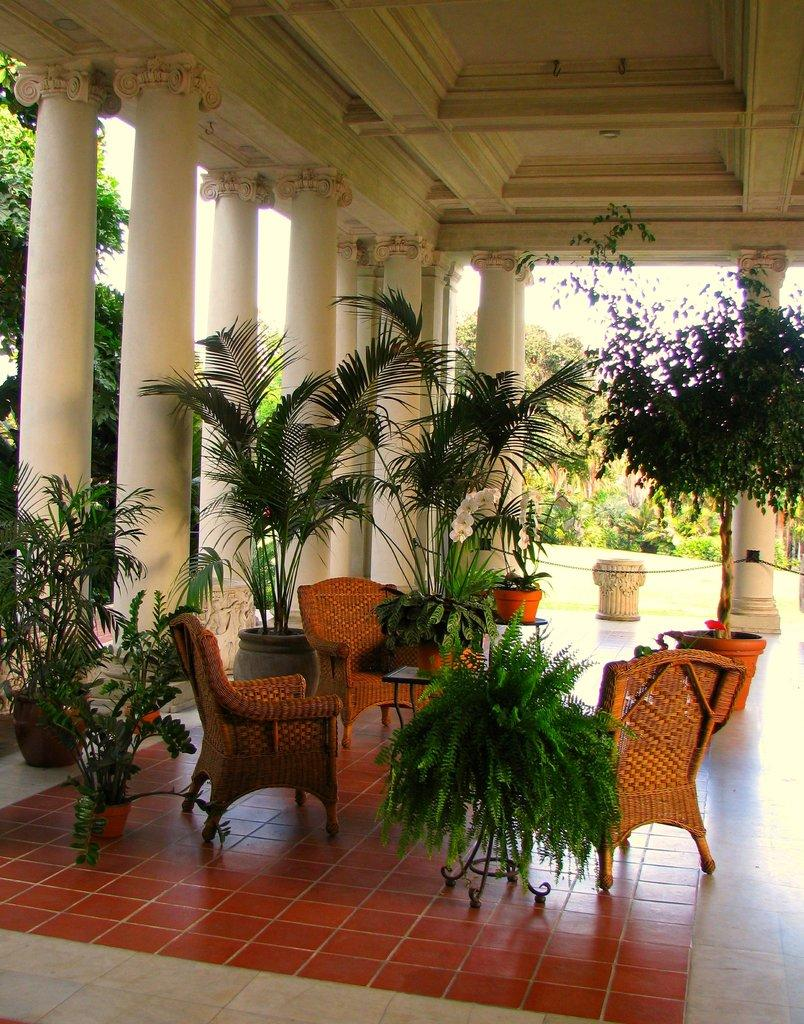What type of furniture can be seen in the image? There are chairs in the image. What other piece of furniture is present in the image? There is a table in the image. What type of greenery is visible in the image? Plants are present in the image. What can be seen in the background of the image? Trees are visible in the image. Can you tell me how many veins are visible on the chair in the image? There are no veins visible on the chair in the image, as veins are not a characteristic of chairs. What type of tool is being used to tighten the wrench in the image? There is no wrench present in the image, so it is not possible to determine if a tool is being used to tighten it. 